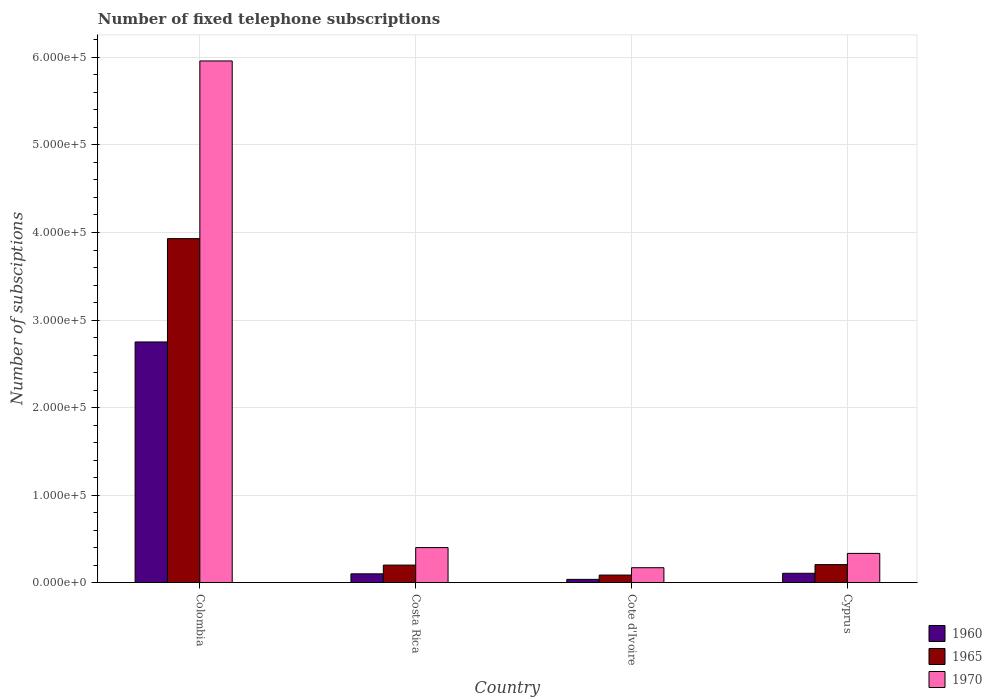How many different coloured bars are there?
Offer a terse response. 3. Are the number of bars on each tick of the X-axis equal?
Give a very brief answer. Yes. How many bars are there on the 4th tick from the right?
Keep it short and to the point. 3. Across all countries, what is the maximum number of fixed telephone subscriptions in 1970?
Give a very brief answer. 5.96e+05. Across all countries, what is the minimum number of fixed telephone subscriptions in 1960?
Your answer should be compact. 3690. In which country was the number of fixed telephone subscriptions in 1970 minimum?
Make the answer very short. Cote d'Ivoire. What is the total number of fixed telephone subscriptions in 1965 in the graph?
Offer a very short reply. 4.42e+05. What is the difference between the number of fixed telephone subscriptions in 1965 in Cote d'Ivoire and that in Cyprus?
Give a very brief answer. -1.20e+04. What is the difference between the number of fixed telephone subscriptions in 1970 in Colombia and the number of fixed telephone subscriptions in 1965 in Cote d'Ivoire?
Provide a short and direct response. 5.87e+05. What is the average number of fixed telephone subscriptions in 1970 per country?
Provide a succinct answer. 1.72e+05. What is the difference between the number of fixed telephone subscriptions of/in 1965 and number of fixed telephone subscriptions of/in 1960 in Colombia?
Make the answer very short. 1.18e+05. In how many countries, is the number of fixed telephone subscriptions in 1965 greater than 580000?
Your response must be concise. 0. What is the ratio of the number of fixed telephone subscriptions in 1960 in Colombia to that in Cote d'Ivoire?
Ensure brevity in your answer.  74.51. Is the number of fixed telephone subscriptions in 1965 in Costa Rica less than that in Cyprus?
Offer a very short reply. Yes. What is the difference between the highest and the second highest number of fixed telephone subscriptions in 1965?
Provide a succinct answer. 3.73e+05. What is the difference between the highest and the lowest number of fixed telephone subscriptions in 1970?
Give a very brief answer. 5.79e+05. Is the sum of the number of fixed telephone subscriptions in 1965 in Colombia and Cote d'Ivoire greater than the maximum number of fixed telephone subscriptions in 1960 across all countries?
Give a very brief answer. Yes. What does the 3rd bar from the left in Costa Rica represents?
Ensure brevity in your answer.  1970. What does the 1st bar from the right in Cyprus represents?
Keep it short and to the point. 1970. Is it the case that in every country, the sum of the number of fixed telephone subscriptions in 1970 and number of fixed telephone subscriptions in 1960 is greater than the number of fixed telephone subscriptions in 1965?
Provide a succinct answer. Yes. How many countries are there in the graph?
Your answer should be very brief. 4. Are the values on the major ticks of Y-axis written in scientific E-notation?
Give a very brief answer. Yes. Does the graph contain grids?
Provide a short and direct response. Yes. How many legend labels are there?
Ensure brevity in your answer.  3. How are the legend labels stacked?
Ensure brevity in your answer.  Vertical. What is the title of the graph?
Offer a very short reply. Number of fixed telephone subscriptions. What is the label or title of the X-axis?
Keep it short and to the point. Country. What is the label or title of the Y-axis?
Your answer should be very brief. Number of subsciptions. What is the Number of subsciptions of 1960 in Colombia?
Your answer should be very brief. 2.75e+05. What is the Number of subsciptions in 1965 in Colombia?
Offer a very short reply. 3.93e+05. What is the Number of subsciptions of 1970 in Colombia?
Offer a terse response. 5.96e+05. What is the Number of subsciptions of 1960 in Cote d'Ivoire?
Make the answer very short. 3690. What is the Number of subsciptions of 1965 in Cote d'Ivoire?
Give a very brief answer. 8600. What is the Number of subsciptions of 1970 in Cote d'Ivoire?
Your answer should be very brief. 1.70e+04. What is the Number of subsciptions of 1960 in Cyprus?
Your answer should be very brief. 1.06e+04. What is the Number of subsciptions of 1965 in Cyprus?
Your response must be concise. 2.06e+04. What is the Number of subsciptions of 1970 in Cyprus?
Give a very brief answer. 3.34e+04. Across all countries, what is the maximum Number of subsciptions of 1960?
Give a very brief answer. 2.75e+05. Across all countries, what is the maximum Number of subsciptions in 1965?
Make the answer very short. 3.93e+05. Across all countries, what is the maximum Number of subsciptions in 1970?
Your response must be concise. 5.96e+05. Across all countries, what is the minimum Number of subsciptions of 1960?
Provide a short and direct response. 3690. Across all countries, what is the minimum Number of subsciptions in 1965?
Provide a succinct answer. 8600. Across all countries, what is the minimum Number of subsciptions in 1970?
Your answer should be compact. 1.70e+04. What is the total Number of subsciptions of 1960 in the graph?
Your answer should be very brief. 2.99e+05. What is the total Number of subsciptions in 1965 in the graph?
Your response must be concise. 4.42e+05. What is the total Number of subsciptions of 1970 in the graph?
Provide a short and direct response. 6.86e+05. What is the difference between the Number of subsciptions of 1960 in Colombia and that in Costa Rica?
Make the answer very short. 2.65e+05. What is the difference between the Number of subsciptions in 1965 in Colombia and that in Costa Rica?
Your response must be concise. 3.73e+05. What is the difference between the Number of subsciptions of 1970 in Colombia and that in Costa Rica?
Provide a short and direct response. 5.56e+05. What is the difference between the Number of subsciptions in 1960 in Colombia and that in Cote d'Ivoire?
Your answer should be very brief. 2.71e+05. What is the difference between the Number of subsciptions of 1965 in Colombia and that in Cote d'Ivoire?
Offer a very short reply. 3.84e+05. What is the difference between the Number of subsciptions in 1970 in Colombia and that in Cote d'Ivoire?
Ensure brevity in your answer.  5.79e+05. What is the difference between the Number of subsciptions of 1960 in Colombia and that in Cyprus?
Make the answer very short. 2.64e+05. What is the difference between the Number of subsciptions of 1965 in Colombia and that in Cyprus?
Your answer should be compact. 3.72e+05. What is the difference between the Number of subsciptions of 1970 in Colombia and that in Cyprus?
Offer a very short reply. 5.63e+05. What is the difference between the Number of subsciptions of 1960 in Costa Rica and that in Cote d'Ivoire?
Offer a terse response. 6310. What is the difference between the Number of subsciptions of 1965 in Costa Rica and that in Cote d'Ivoire?
Offer a terse response. 1.14e+04. What is the difference between the Number of subsciptions in 1970 in Costa Rica and that in Cote d'Ivoire?
Provide a short and direct response. 2.30e+04. What is the difference between the Number of subsciptions in 1960 in Costa Rica and that in Cyprus?
Your answer should be compact. -630. What is the difference between the Number of subsciptions of 1965 in Costa Rica and that in Cyprus?
Your answer should be compact. -550. What is the difference between the Number of subsciptions in 1970 in Costa Rica and that in Cyprus?
Keep it short and to the point. 6641. What is the difference between the Number of subsciptions of 1960 in Cote d'Ivoire and that in Cyprus?
Keep it short and to the point. -6940. What is the difference between the Number of subsciptions in 1965 in Cote d'Ivoire and that in Cyprus?
Your response must be concise. -1.20e+04. What is the difference between the Number of subsciptions in 1970 in Cote d'Ivoire and that in Cyprus?
Offer a very short reply. -1.64e+04. What is the difference between the Number of subsciptions of 1960 in Colombia and the Number of subsciptions of 1965 in Costa Rica?
Make the answer very short. 2.55e+05. What is the difference between the Number of subsciptions in 1960 in Colombia and the Number of subsciptions in 1970 in Costa Rica?
Make the answer very short. 2.35e+05. What is the difference between the Number of subsciptions in 1965 in Colombia and the Number of subsciptions in 1970 in Costa Rica?
Your answer should be very brief. 3.53e+05. What is the difference between the Number of subsciptions in 1960 in Colombia and the Number of subsciptions in 1965 in Cote d'Ivoire?
Provide a succinct answer. 2.66e+05. What is the difference between the Number of subsciptions in 1960 in Colombia and the Number of subsciptions in 1970 in Cote d'Ivoire?
Your response must be concise. 2.58e+05. What is the difference between the Number of subsciptions in 1965 in Colombia and the Number of subsciptions in 1970 in Cote d'Ivoire?
Make the answer very short. 3.76e+05. What is the difference between the Number of subsciptions of 1960 in Colombia and the Number of subsciptions of 1965 in Cyprus?
Offer a terse response. 2.54e+05. What is the difference between the Number of subsciptions in 1960 in Colombia and the Number of subsciptions in 1970 in Cyprus?
Ensure brevity in your answer.  2.42e+05. What is the difference between the Number of subsciptions of 1965 in Colombia and the Number of subsciptions of 1970 in Cyprus?
Ensure brevity in your answer.  3.60e+05. What is the difference between the Number of subsciptions in 1960 in Costa Rica and the Number of subsciptions in 1965 in Cote d'Ivoire?
Ensure brevity in your answer.  1400. What is the difference between the Number of subsciptions in 1960 in Costa Rica and the Number of subsciptions in 1970 in Cote d'Ivoire?
Keep it short and to the point. -7000. What is the difference between the Number of subsciptions of 1965 in Costa Rica and the Number of subsciptions of 1970 in Cote d'Ivoire?
Offer a very short reply. 3000. What is the difference between the Number of subsciptions of 1960 in Costa Rica and the Number of subsciptions of 1965 in Cyprus?
Ensure brevity in your answer.  -1.06e+04. What is the difference between the Number of subsciptions of 1960 in Costa Rica and the Number of subsciptions of 1970 in Cyprus?
Give a very brief answer. -2.34e+04. What is the difference between the Number of subsciptions of 1965 in Costa Rica and the Number of subsciptions of 1970 in Cyprus?
Keep it short and to the point. -1.34e+04. What is the difference between the Number of subsciptions in 1960 in Cote d'Ivoire and the Number of subsciptions in 1965 in Cyprus?
Ensure brevity in your answer.  -1.69e+04. What is the difference between the Number of subsciptions of 1960 in Cote d'Ivoire and the Number of subsciptions of 1970 in Cyprus?
Offer a very short reply. -2.97e+04. What is the difference between the Number of subsciptions of 1965 in Cote d'Ivoire and the Number of subsciptions of 1970 in Cyprus?
Keep it short and to the point. -2.48e+04. What is the average Number of subsciptions in 1960 per country?
Offer a very short reply. 7.48e+04. What is the average Number of subsciptions in 1965 per country?
Your answer should be compact. 1.11e+05. What is the average Number of subsciptions in 1970 per country?
Give a very brief answer. 1.72e+05. What is the difference between the Number of subsciptions of 1960 and Number of subsciptions of 1965 in Colombia?
Make the answer very short. -1.18e+05. What is the difference between the Number of subsciptions in 1960 and Number of subsciptions in 1970 in Colombia?
Ensure brevity in your answer.  -3.21e+05. What is the difference between the Number of subsciptions of 1965 and Number of subsciptions of 1970 in Colombia?
Provide a short and direct response. -2.03e+05. What is the difference between the Number of subsciptions of 1960 and Number of subsciptions of 1965 in Costa Rica?
Your answer should be compact. -10000. What is the difference between the Number of subsciptions of 1960 and Number of subsciptions of 1970 in Costa Rica?
Offer a terse response. -3.00e+04. What is the difference between the Number of subsciptions in 1965 and Number of subsciptions in 1970 in Costa Rica?
Provide a short and direct response. -2.00e+04. What is the difference between the Number of subsciptions of 1960 and Number of subsciptions of 1965 in Cote d'Ivoire?
Ensure brevity in your answer.  -4910. What is the difference between the Number of subsciptions of 1960 and Number of subsciptions of 1970 in Cote d'Ivoire?
Your response must be concise. -1.33e+04. What is the difference between the Number of subsciptions in 1965 and Number of subsciptions in 1970 in Cote d'Ivoire?
Provide a short and direct response. -8400. What is the difference between the Number of subsciptions of 1960 and Number of subsciptions of 1965 in Cyprus?
Make the answer very short. -9920. What is the difference between the Number of subsciptions in 1960 and Number of subsciptions in 1970 in Cyprus?
Offer a very short reply. -2.27e+04. What is the difference between the Number of subsciptions in 1965 and Number of subsciptions in 1970 in Cyprus?
Offer a very short reply. -1.28e+04. What is the ratio of the Number of subsciptions of 1960 in Colombia to that in Costa Rica?
Offer a very short reply. 27.49. What is the ratio of the Number of subsciptions in 1965 in Colombia to that in Costa Rica?
Your answer should be compact. 19.65. What is the ratio of the Number of subsciptions of 1960 in Colombia to that in Cote d'Ivoire?
Your answer should be compact. 74.51. What is the ratio of the Number of subsciptions of 1965 in Colombia to that in Cote d'Ivoire?
Your answer should be compact. 45.7. What is the ratio of the Number of subsciptions in 1970 in Colombia to that in Cote d'Ivoire?
Provide a succinct answer. 35.06. What is the ratio of the Number of subsciptions in 1960 in Colombia to that in Cyprus?
Your answer should be very brief. 25.86. What is the ratio of the Number of subsciptions of 1965 in Colombia to that in Cyprus?
Provide a short and direct response. 19.12. What is the ratio of the Number of subsciptions of 1970 in Colombia to that in Cyprus?
Offer a terse response. 17.87. What is the ratio of the Number of subsciptions in 1960 in Costa Rica to that in Cote d'Ivoire?
Offer a very short reply. 2.71. What is the ratio of the Number of subsciptions in 1965 in Costa Rica to that in Cote d'Ivoire?
Your answer should be very brief. 2.33. What is the ratio of the Number of subsciptions in 1970 in Costa Rica to that in Cote d'Ivoire?
Keep it short and to the point. 2.35. What is the ratio of the Number of subsciptions of 1960 in Costa Rica to that in Cyprus?
Ensure brevity in your answer.  0.94. What is the ratio of the Number of subsciptions of 1965 in Costa Rica to that in Cyprus?
Your response must be concise. 0.97. What is the ratio of the Number of subsciptions of 1970 in Costa Rica to that in Cyprus?
Your answer should be compact. 1.2. What is the ratio of the Number of subsciptions in 1960 in Cote d'Ivoire to that in Cyprus?
Offer a terse response. 0.35. What is the ratio of the Number of subsciptions of 1965 in Cote d'Ivoire to that in Cyprus?
Your answer should be very brief. 0.42. What is the ratio of the Number of subsciptions in 1970 in Cote d'Ivoire to that in Cyprus?
Ensure brevity in your answer.  0.51. What is the difference between the highest and the second highest Number of subsciptions in 1960?
Provide a short and direct response. 2.64e+05. What is the difference between the highest and the second highest Number of subsciptions in 1965?
Offer a very short reply. 3.72e+05. What is the difference between the highest and the second highest Number of subsciptions of 1970?
Keep it short and to the point. 5.56e+05. What is the difference between the highest and the lowest Number of subsciptions of 1960?
Offer a terse response. 2.71e+05. What is the difference between the highest and the lowest Number of subsciptions of 1965?
Your response must be concise. 3.84e+05. What is the difference between the highest and the lowest Number of subsciptions in 1970?
Make the answer very short. 5.79e+05. 